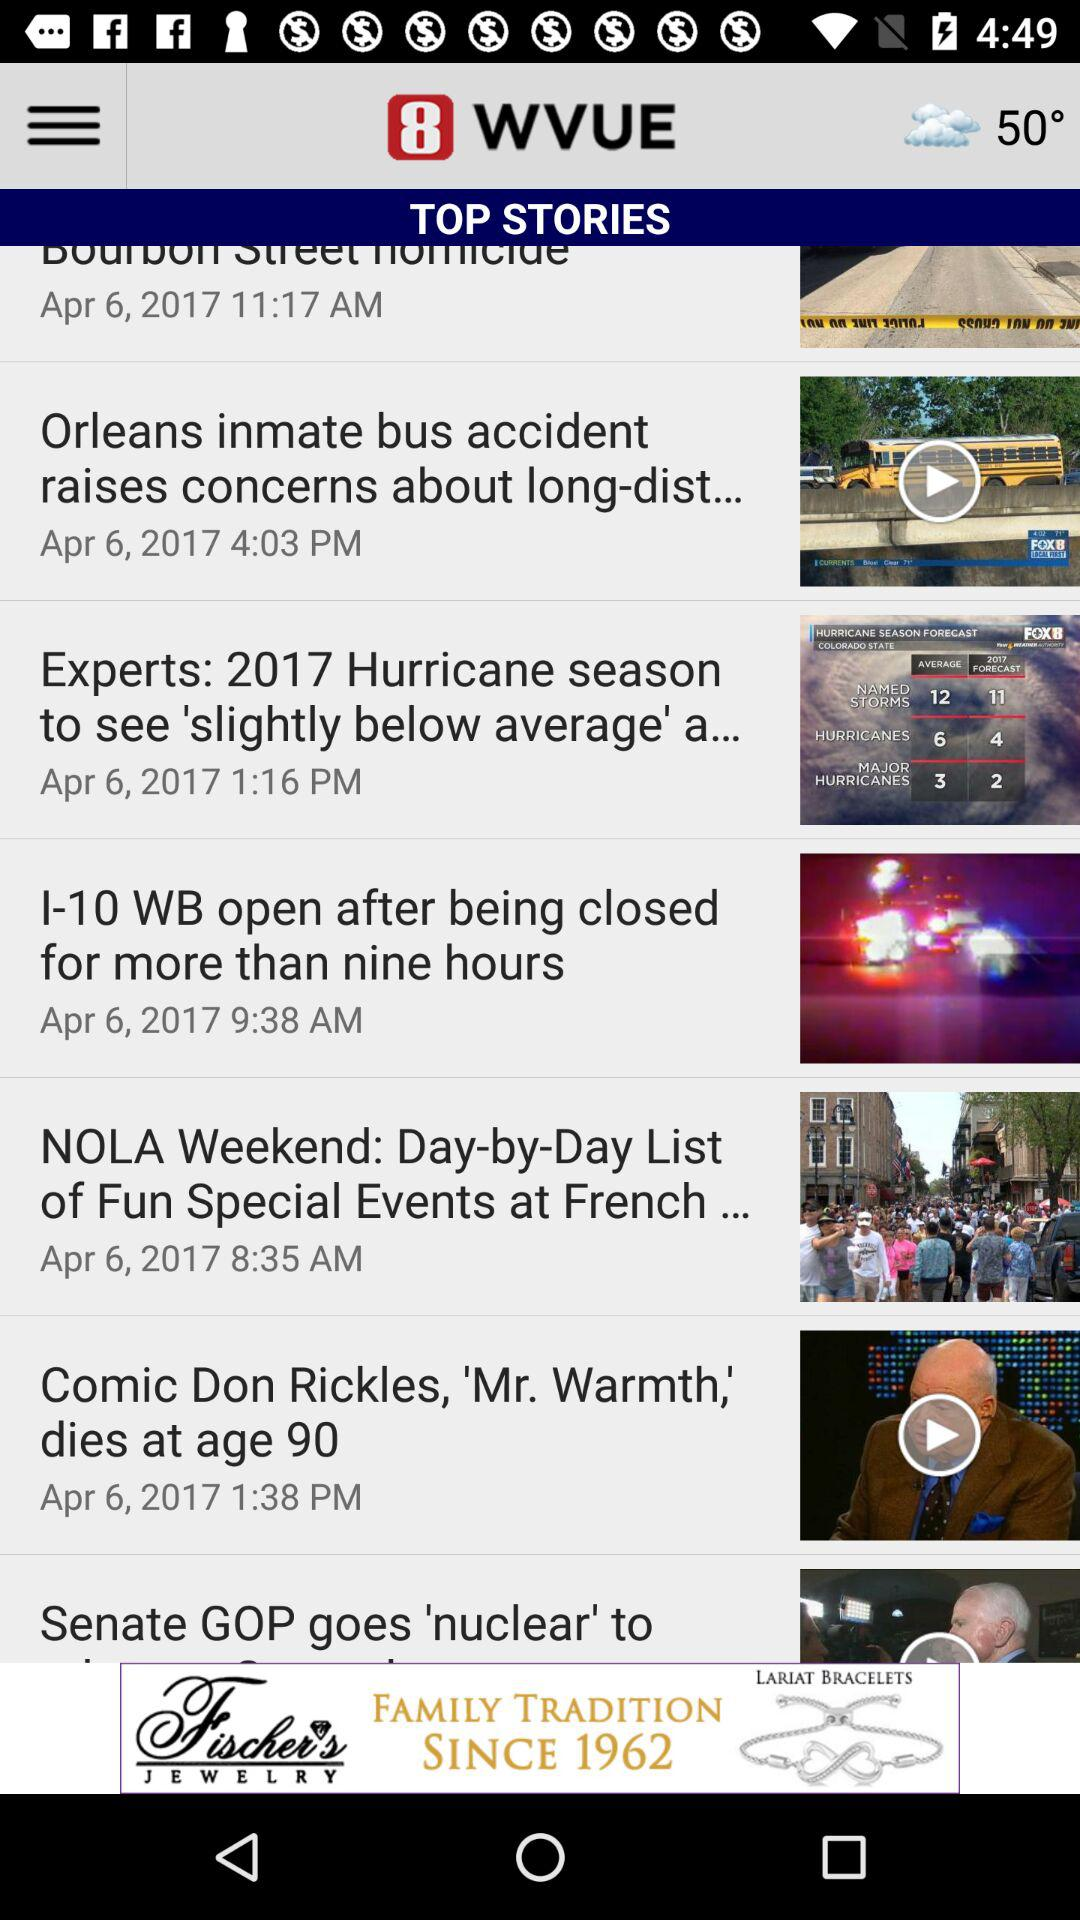When was the news "Comic Don Rickles, 'Mr. Warmth,' dies at age 90" uploaded? The news "Comic Don Rickles, 'Mr. Warmth,' dies at age 90" was uploaded on April 6, 2017 at 1:38 PM. 